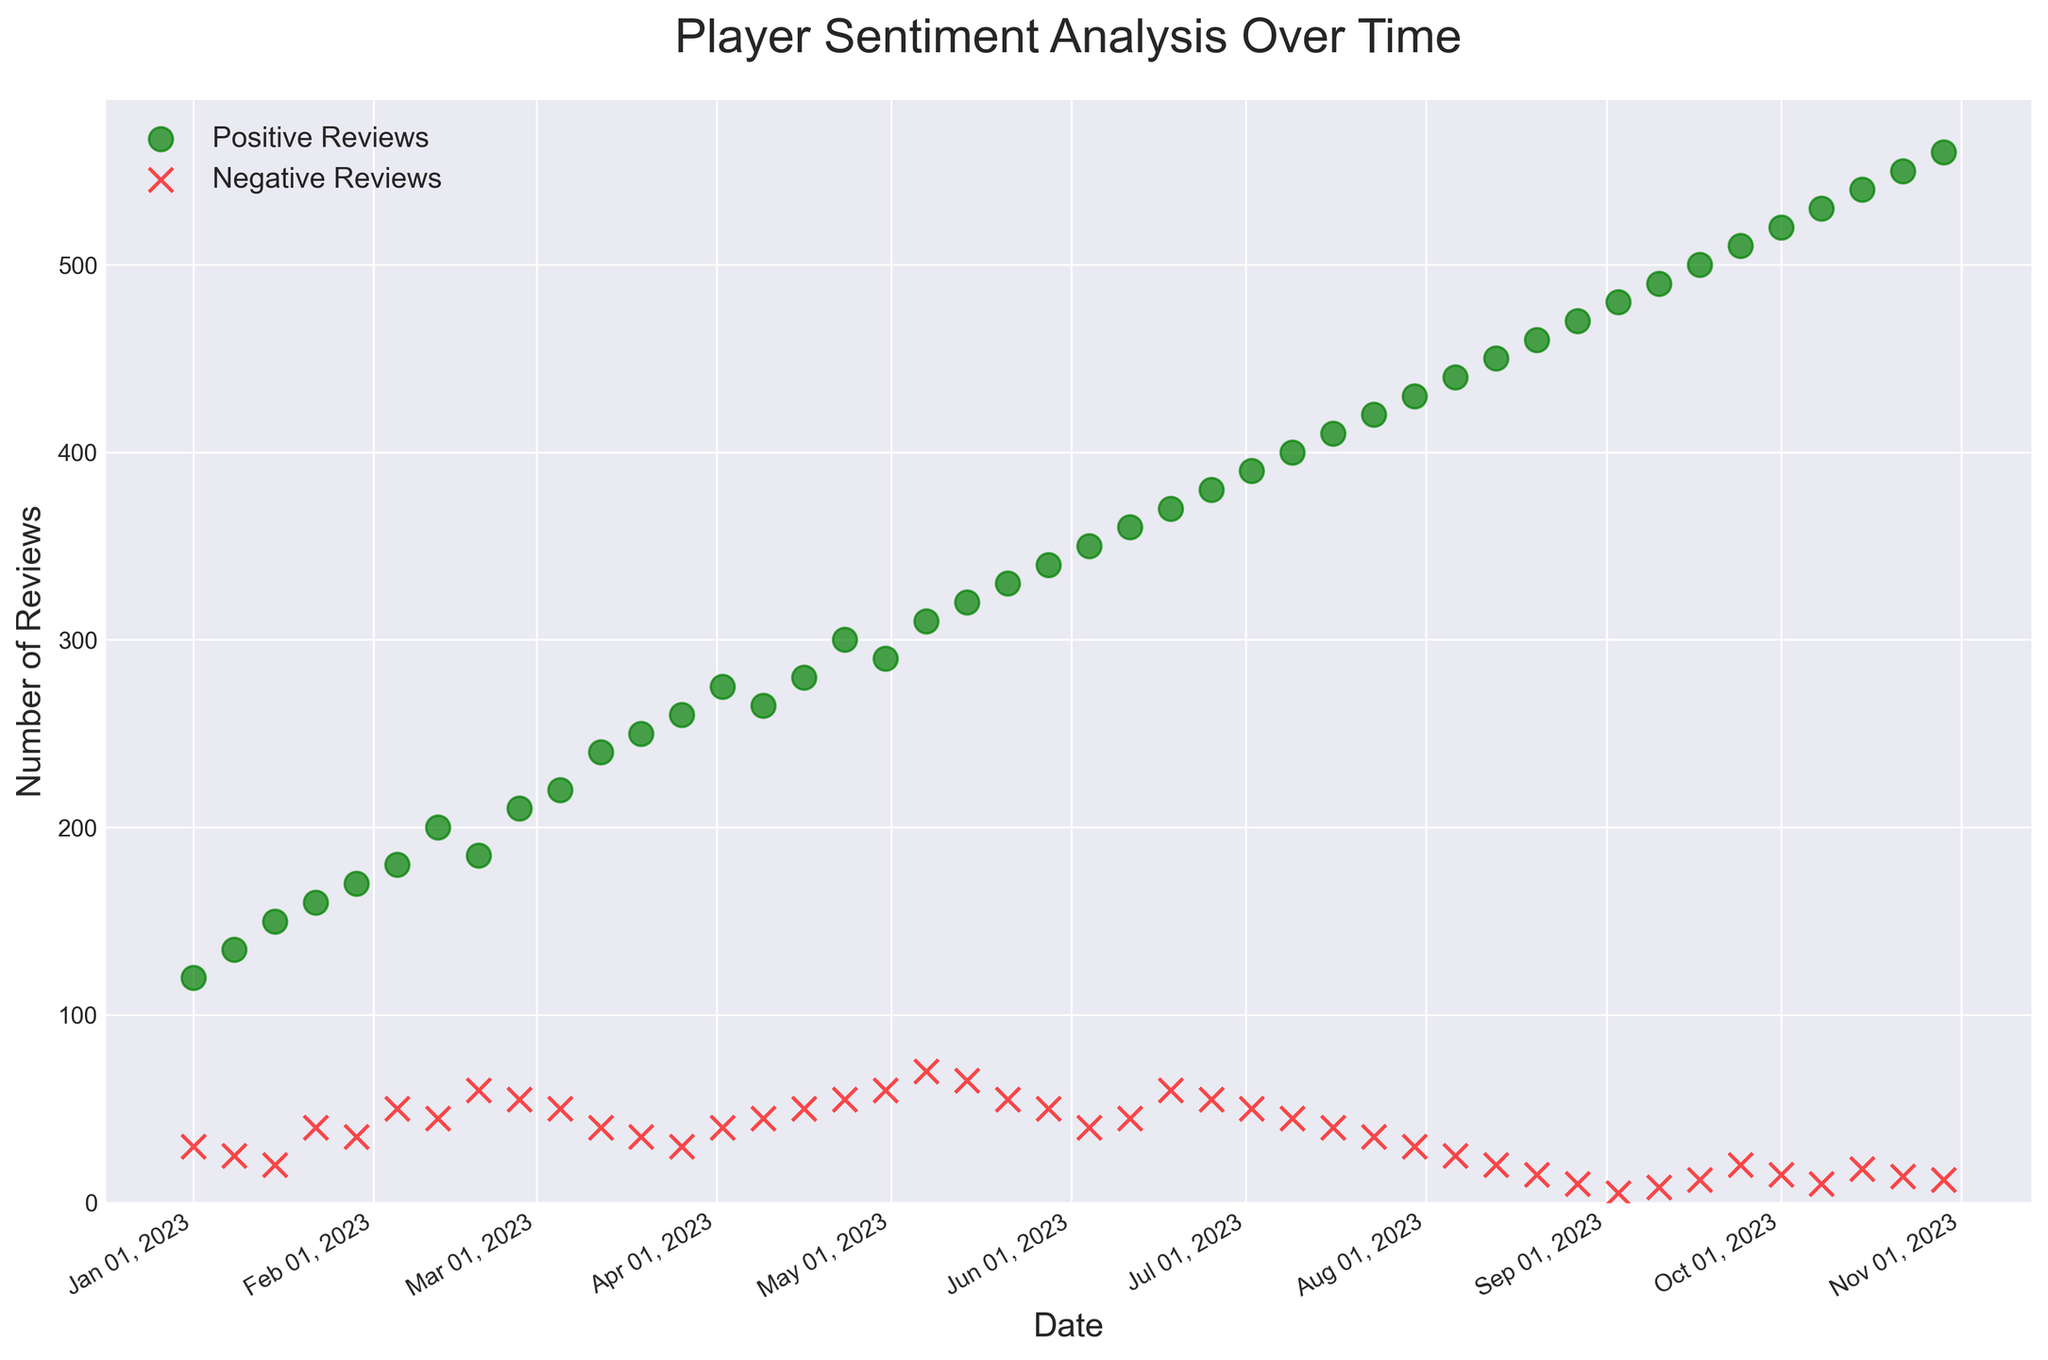What is the overall trend for positive reviews from January to October 2023? By observing the scatter plot, the green dots (representing positive reviews) form an upward trend from January to October 2023, indicating an increase in positive reviews over time.
Answer: Increasing What week saw the highest number of negative reviews? By looking at the scatter plot, the red "x" corresponding to the highest value indicates the peak of negative reviews. This occurs during the week of May 7, 2023, with 70 negative reviews.
Answer: Week of May 7, 2023 How many more positive reviews were there compared to negative reviews on January 1, 2023? Positive reviews were 120, and negative reviews were 30 on January 1, 2023. The difference is 120 - 30 = 90 positive reviews.
Answer: 90 What is the average number of positive reviews from July 1, 2023, to October 1, 2023? The positive reviews for each of the selected dates are 390, 400, 410, 420, 430, 440, 450, 460, 470, 480, 490, 500, 510, 520. Sum these values getting 7,740. There are 14 data points, so the average is 7,740 / 14 = 553.
Answer: 553 Which month experienced the largest difference between positive and negative reviews? July experienced large differences in positive versus gap reviews:
- Weeks in July: (July 2: 390-50=340, July 9: 400-45=355, July 16: 410-40=270, July 23: 420-35=385, July 30: 430-30=400).
By comparing resulting differences, we find that July 30 has the largest difference: 430 - 30 = 400.
Answer: July 30 How did the number of negative reviews in August compare to those in January? For January, the negative reviews are 30, 25, 20, 40, 35. For August, they are 25, 20, 15, 10. The averages: January (150/5=30), August(70/4=17.5). Hence, January has more negative reviews on average.
Answer: January had more negative reviews What is the general color used to represent negative reviews in the scatter plot? The red 'x' marks are used to represent negative reviews in the scatter plot.
Answer: Red When does the number of positive reviews exceed 450 for the first time? By observing the scatter plot's green dots, the first instance where positive reviews exceed 450 is on August 13, 2023, with 450 reviews.
Answer: Week of August 13, 2023 What visual differences can you observe between the scatter plots of positive and negative reviews? Positive reviews are represented by green circles, while negative reviews are represented by red x's. Additionally, positive reviews are generally higher on the y-axis compared to negative reviews, indicating higher values.
Answer: Green circles for positive, red x's for negative Compare the highest number of positive reviews to the highest number of negative reviews observed in the plot. The highest positive reviews are 560 on October 29, 2023. The highest negative reviews are 70 on May 7, 2023.
Answer: 560 vs. 70 